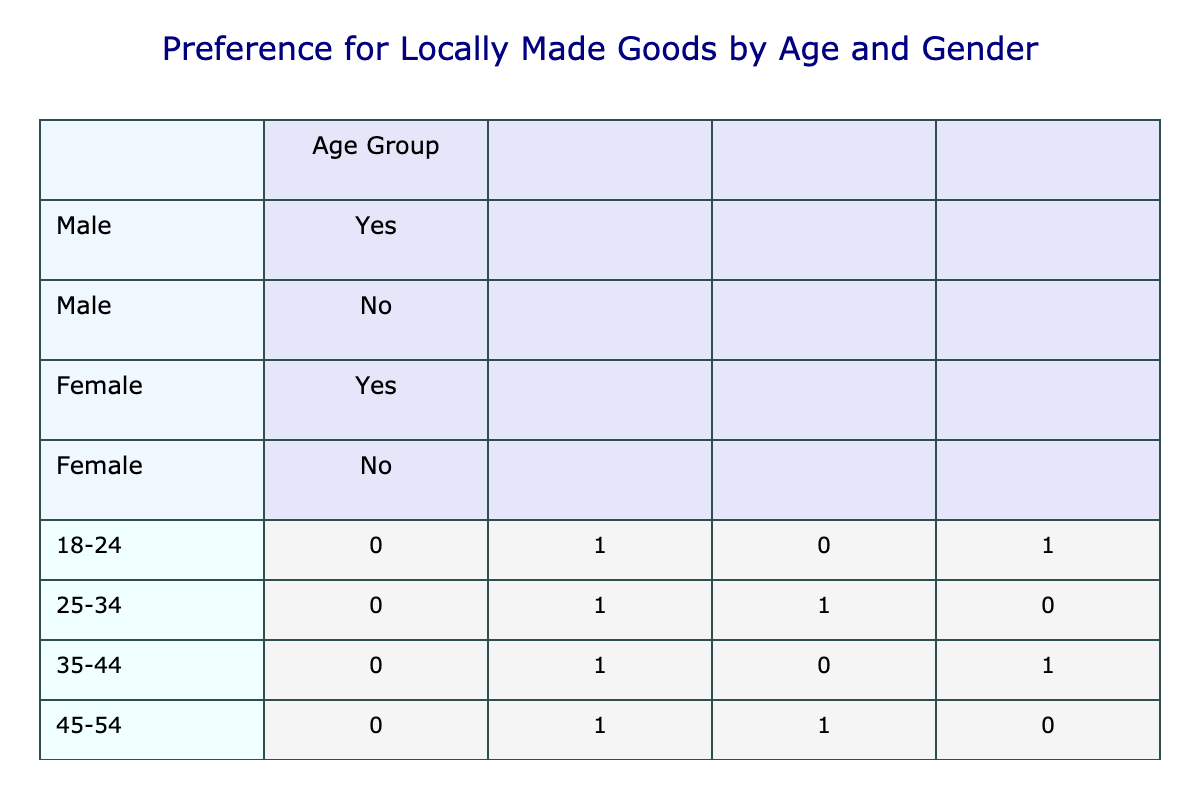What is the total number of males who prefer locally made goods? From the table, we look for males under the "Yes" column across all age groups. The males who prefer locally made goods are in the age groups of 18-24, 35-44, 55-64, and 65+, which sums to 4.
Answer: 4 How many females aged 45-54 prefer locally made goods? Referring to the table, we only need to look at the age group of 45-54 and see the corresponding preference for locally made goods. The female in this age group answers "Yes," so the count is 1.
Answer: 1 What is the preference for locally made goods among the 25-34 age group? For the age group 25-34, we need to check the gender counts. Males do not prefer locally made goods ("No"), while females do prefer them ("Yes"). Therefore, there is a total of 1 for females and 0 for males.
Answer: 1 female, 0 males Which age group has the highest preference for locally made goods? To find the age group with the highest preference, we tally the responses for "Yes" across all groups: 4 in 18-24 (2 males, 2 females), 1 in 25-34 (1 female), 2 in 35-44 (1 male, 1 female), 1 in 45-54 (1 female), 1 in 55-64 (1 male), and 2 in 65+ (1 male, 1 female). The highest total is 4 in the 18-24 age group.
Answer: 18-24 Are more males or females interested in locally made goods in the 55-64 age group? In the 55-64 age group, we have 1 male who prefers locally made goods and 0 females. So we determine that males are more interested in this age group.
Answer: Males What is the difference in the number of males and females who do not prefer locally made goods? Analyzing the "No" responses, we find that 1 male (age 25-34) does not prefer locally made goods, and 1 female (also in the 55-64 group) doesn't as well. Hence, the difference is 1 male - 1 female = 0.
Answer: 0 Is it true that all males aged 65+ prefer locally made goods? Looking specifically at the age group of 65+, we see that both males and females have a preference of "Yes" for locally made goods. Therefore, it is true that all males in this group prefer such goods.
Answer: Yes If we combine the total number of males and females who prefer locally made goods, what is that total? Adding all males and females who prefer locally made goods yields: 2 (18-24 male and female) + 1 (25-34 female) + 2 (35-44 male and female) + 1 (45-54 female) + 1 (55-64 male) + 2 (65+ male and female) = 9.
Answer: 9 How many females prefer locally made goods from the age groups 25-34 and 45-54 combined? For 25-34, there is 1 female who prefers locally made goods. For 45-54, there is also 1 female. Adding these together: 1 (25-34) + 1 (45-54) = 2 females that prefer locally made goods.
Answer: 2 